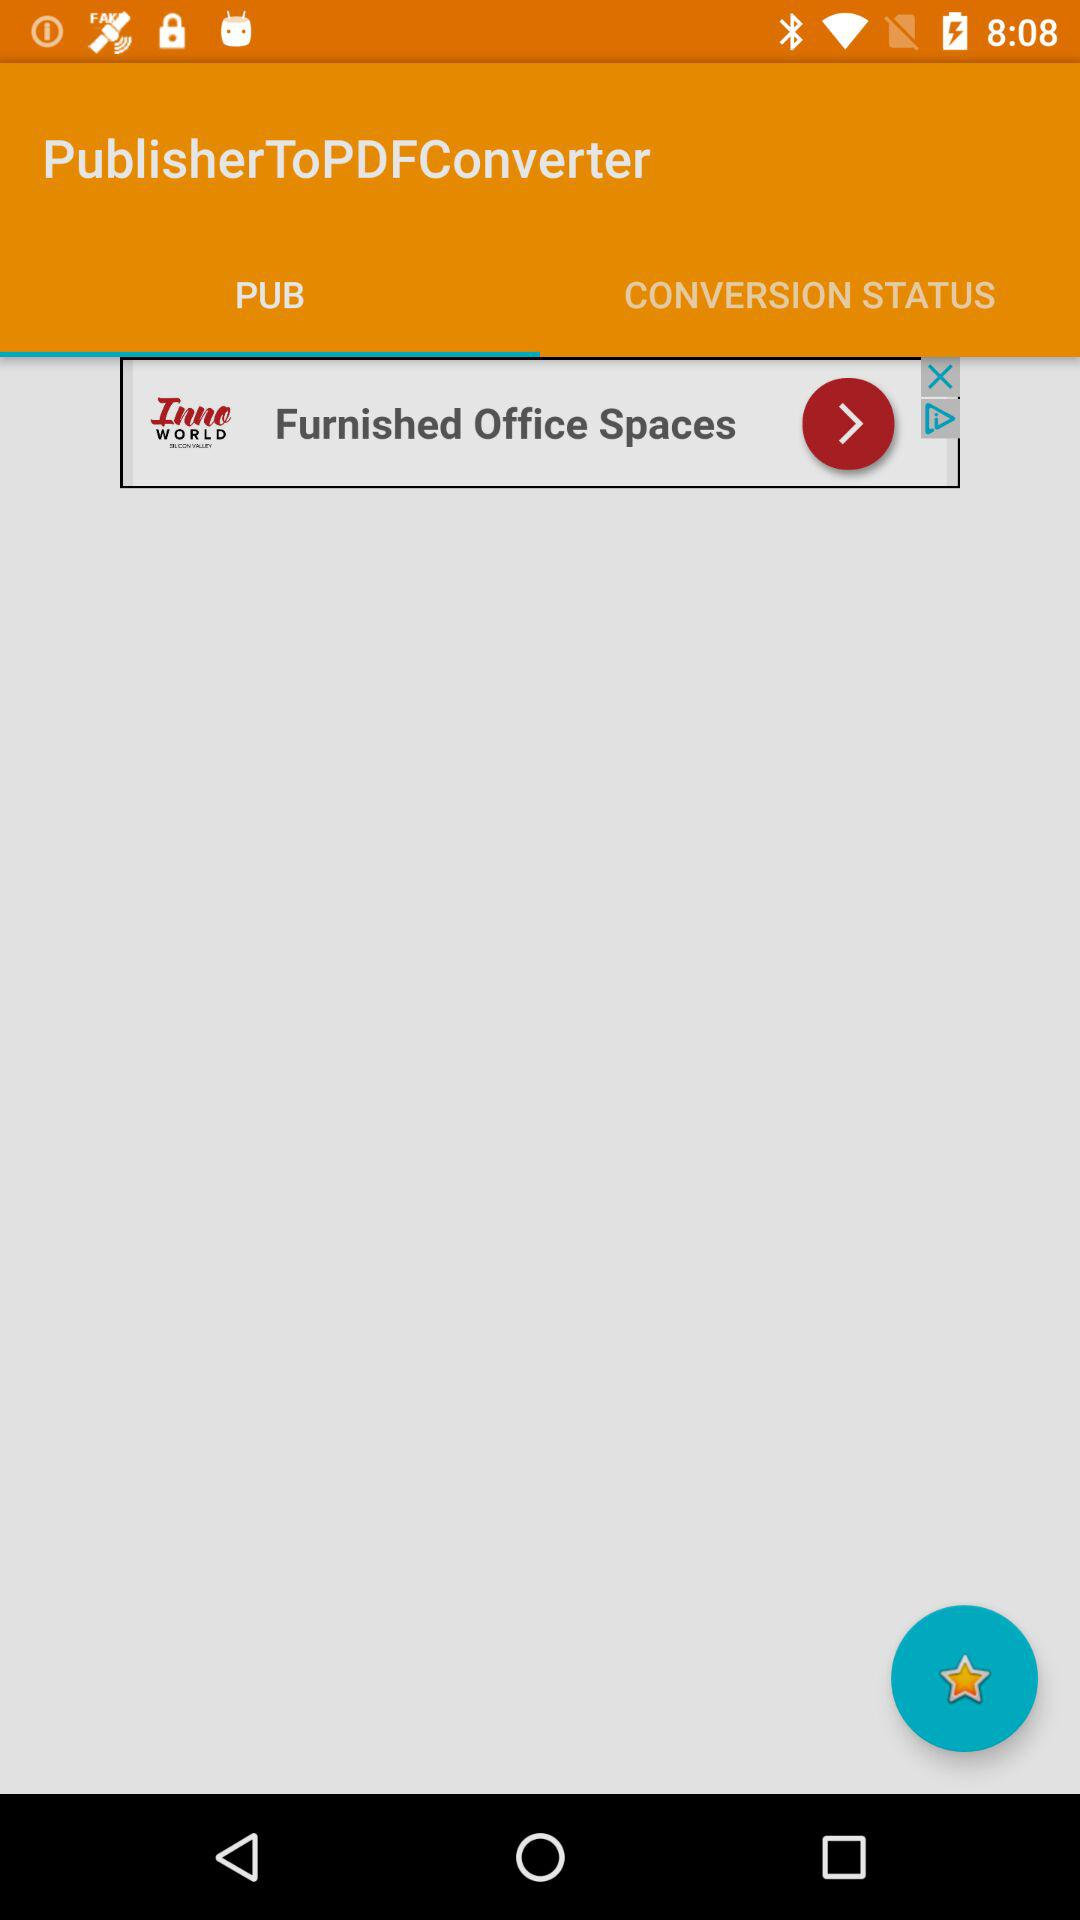What is the application name? The application name is "PublisherToPDFConverter". 